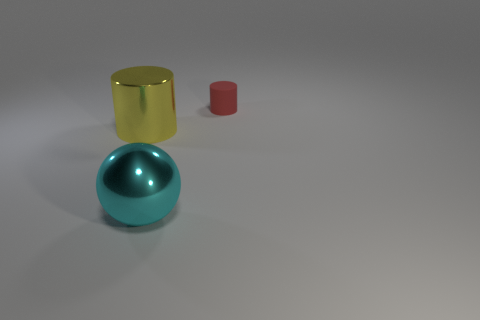Are there any other things that are the same size as the red matte object?
Your answer should be compact. No. What number of objects are both to the left of the tiny red matte object and on the right side of the big cylinder?
Offer a very short reply. 1. How many objects are either things on the left side of the small rubber thing or cylinders that are right of the large cyan ball?
Provide a short and direct response. 3. How many other objects are there of the same size as the metallic cylinder?
Give a very brief answer. 1. The red matte thing behind the metallic thing that is behind the cyan shiny object is what shape?
Ensure brevity in your answer.  Cylinder. The metal sphere is what color?
Make the answer very short. Cyan. Is there a cyan shiny sphere?
Your response must be concise. Yes. Are there any large shiny things on the right side of the big yellow metallic cylinder?
Provide a short and direct response. Yes. There is a red object that is the same shape as the yellow thing; what is it made of?
Offer a terse response. Rubber. Is there any other thing that is the same material as the small thing?
Your response must be concise. No. 